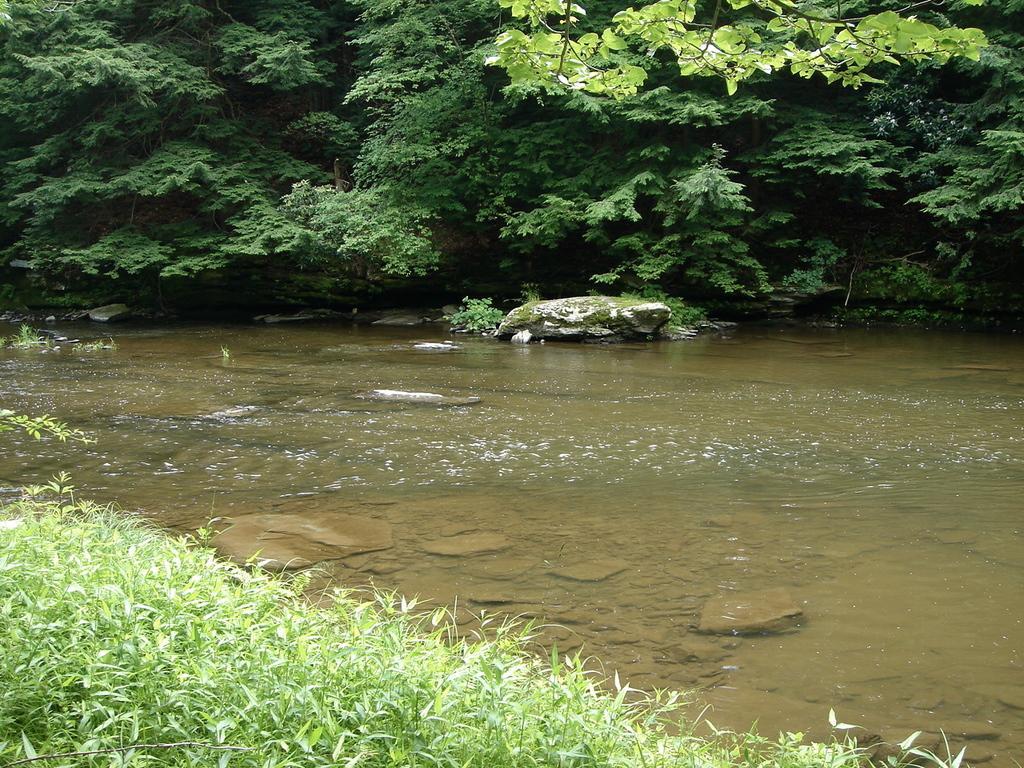Can you describe this image briefly? In this image there is a lake, in front of the image there is grass, in the background of the image there are trees and there are rocks. 